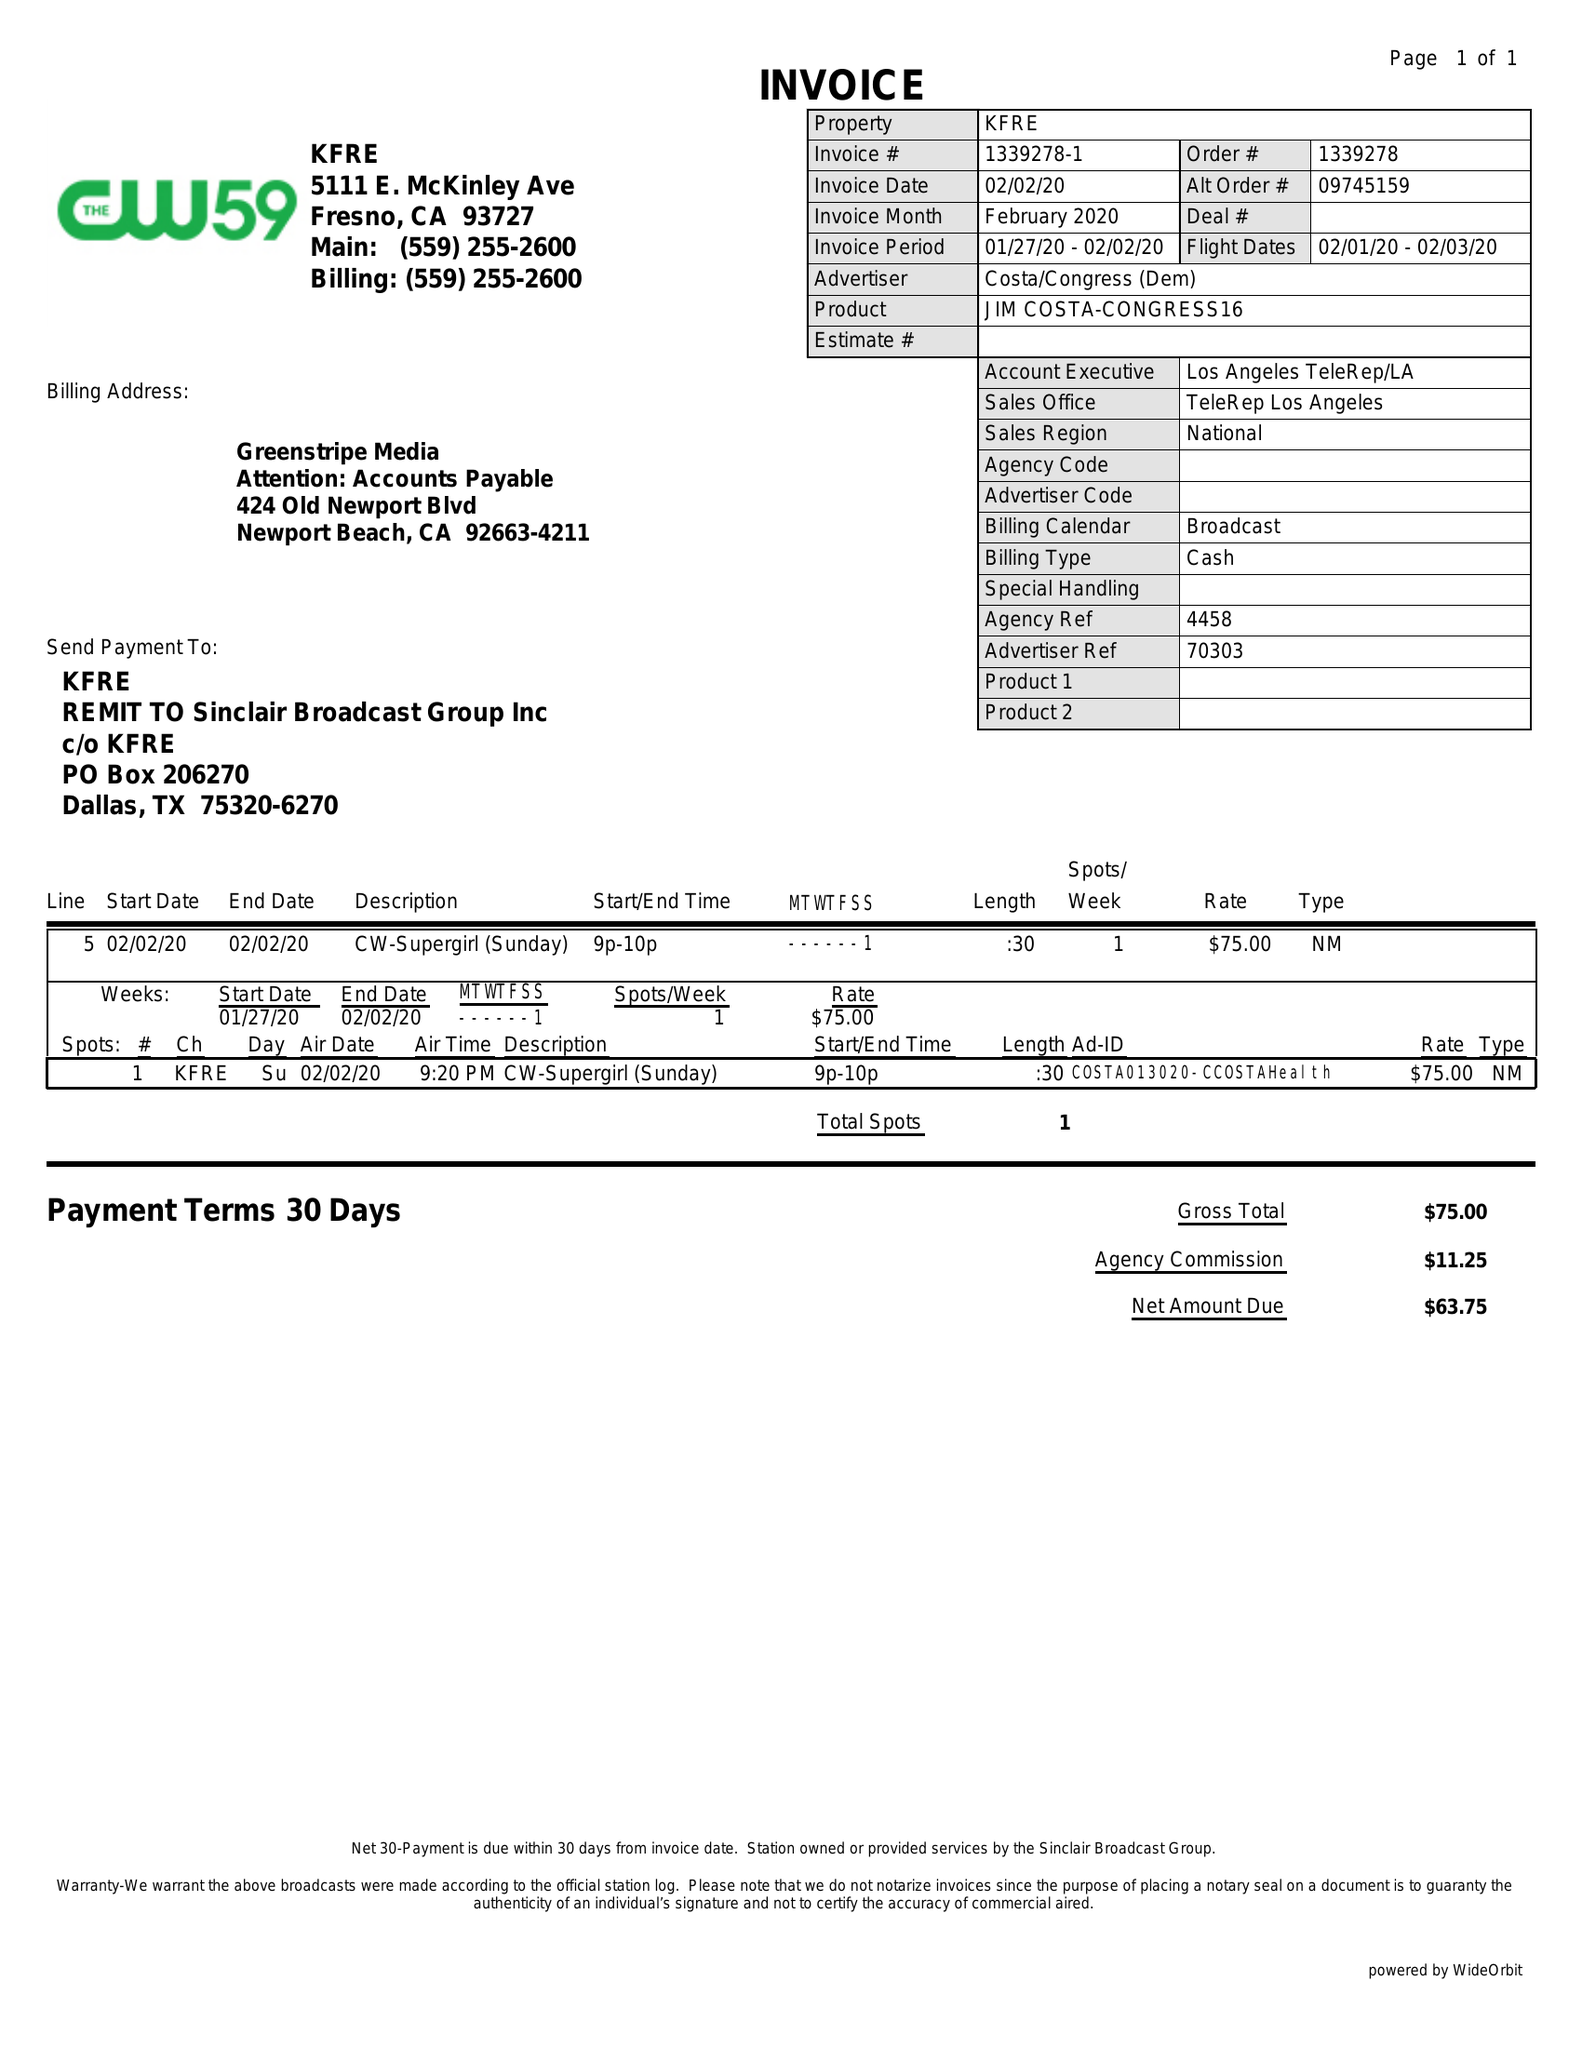What is the value for the advertiser?
Answer the question using a single word or phrase. COSTA/CONGRESS(DEM) 